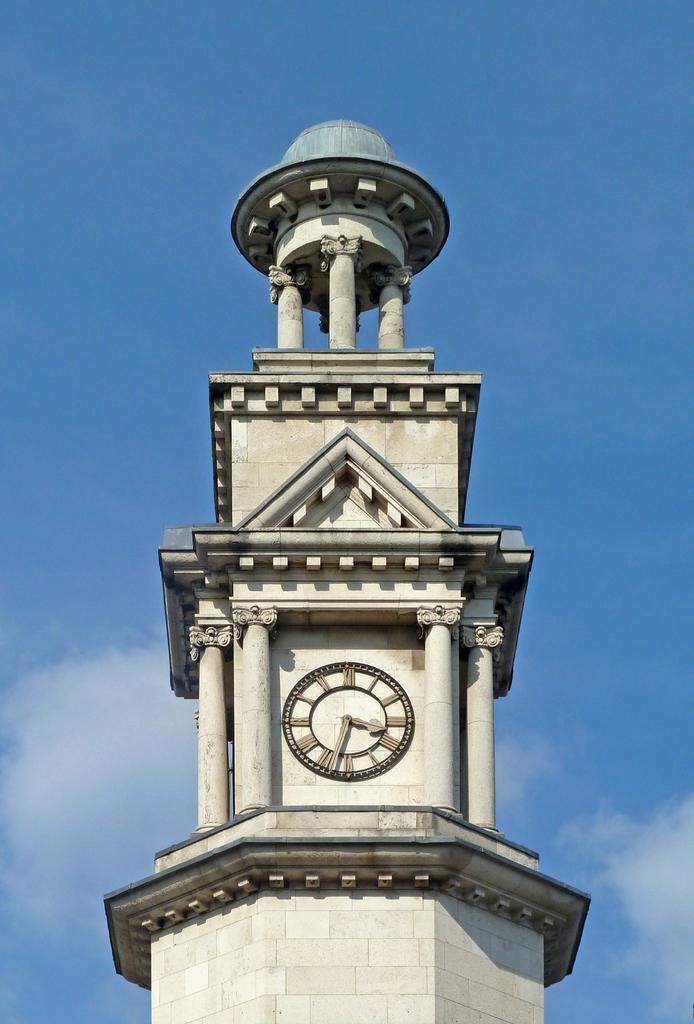<image>
Share a concise interpretation of the image provided. A tower has a clock on it that shows the time as 3:32. 